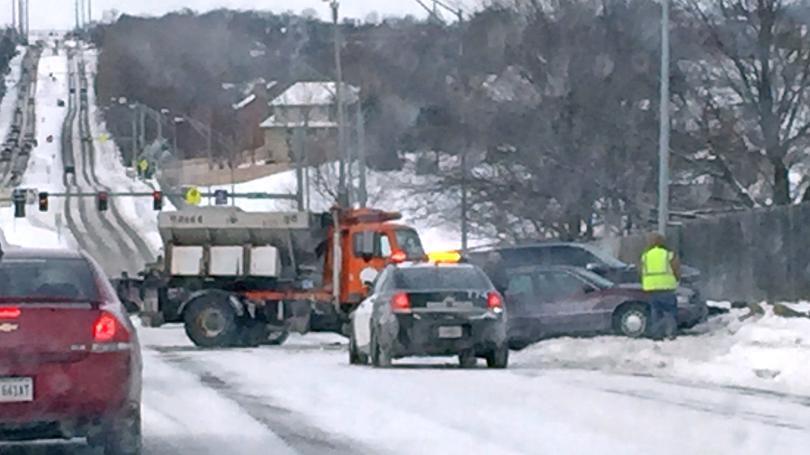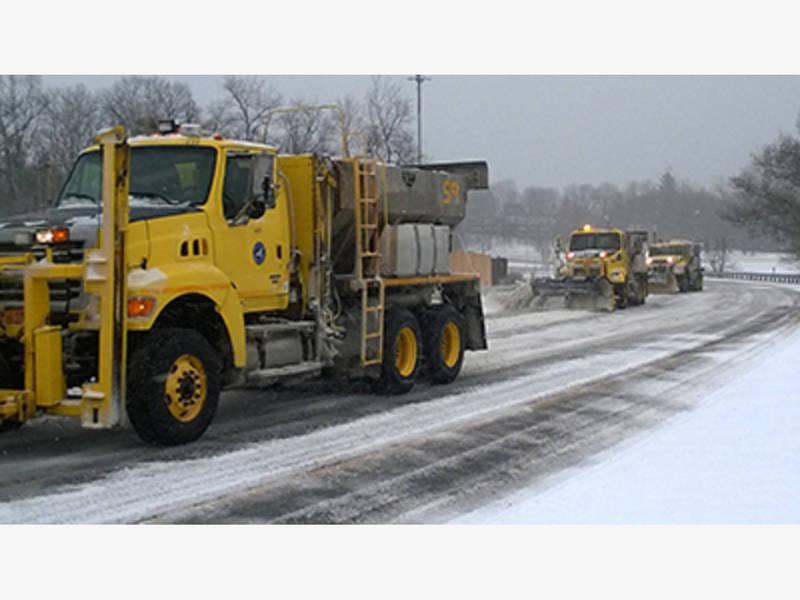The first image is the image on the left, the second image is the image on the right. Considering the images on both sides, is "The left image shows an unattached yellow snow plow with its back side facing the camera." valid? Answer yes or no. No. 